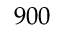<formula> <loc_0><loc_0><loc_500><loc_500>9 0 0</formula> 